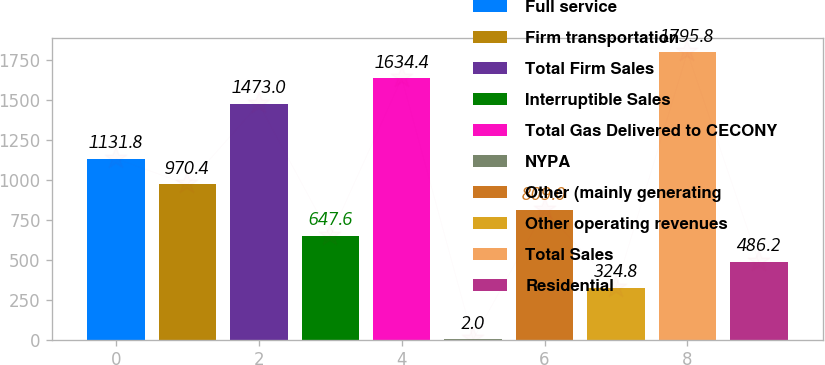Convert chart to OTSL. <chart><loc_0><loc_0><loc_500><loc_500><bar_chart><fcel>Full service<fcel>Firm transportation<fcel>Total Firm Sales<fcel>Interruptible Sales<fcel>Total Gas Delivered to CECONY<fcel>NYPA<fcel>Other (mainly generating<fcel>Other operating revenues<fcel>Total Sales<fcel>Residential<nl><fcel>1131.8<fcel>970.4<fcel>1473<fcel>647.6<fcel>1634.4<fcel>2<fcel>809<fcel>324.8<fcel>1795.8<fcel>486.2<nl></chart> 